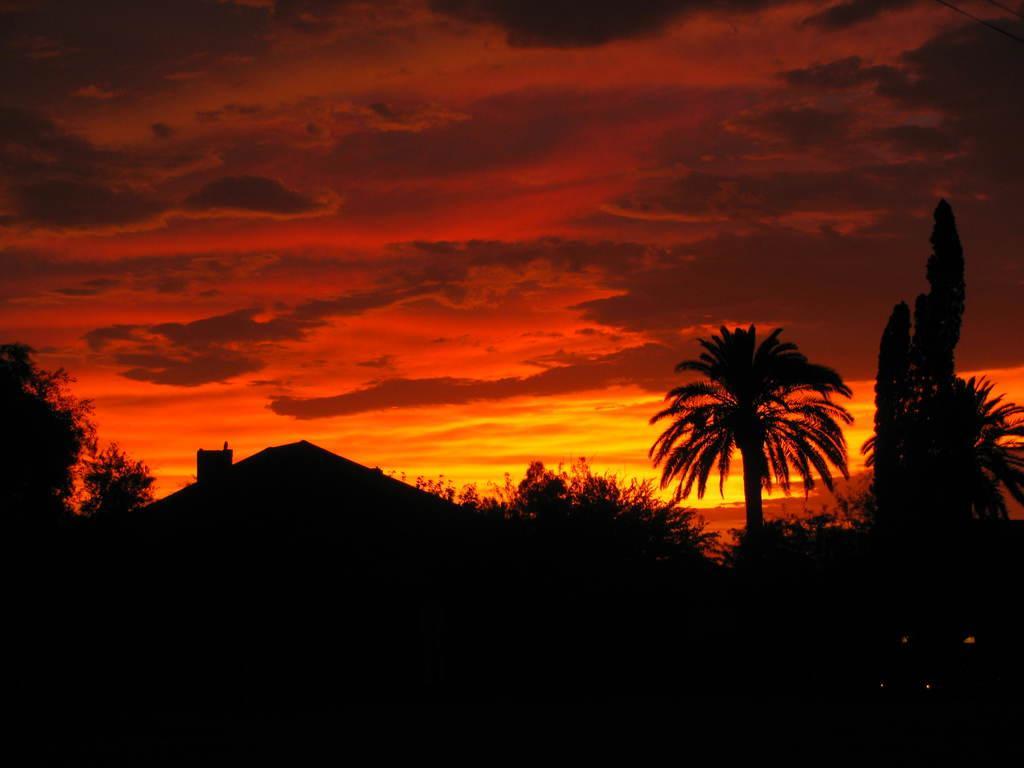In one or two sentences, can you explain what this image depicts? This image is dark where we can see houses, trees and the orange colored sky with clouds. 